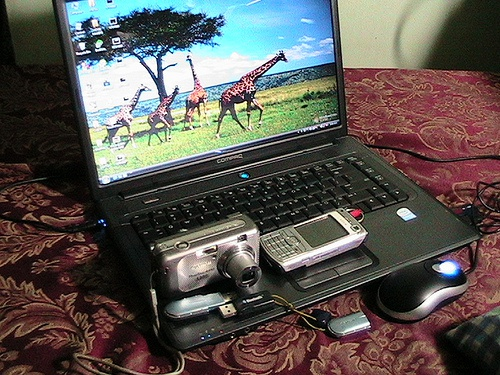Describe the objects in this image and their specific colors. I can see laptop in black, white, gray, and lightblue tones, bed in black, maroon, and brown tones, cell phone in black, gray, darkgray, and white tones, mouse in black, white, gray, and darkgray tones, and giraffe in black, white, gray, and maroon tones in this image. 